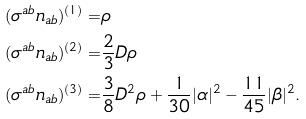Convert formula to latex. <formula><loc_0><loc_0><loc_500><loc_500>( \sigma ^ { a b } n _ { a b } ) ^ { ( 1 ) } = & \rho \\ ( \sigma ^ { a b } n _ { a b } ) ^ { ( 2 ) } = & \frac { 2 } { 3 } D \rho \\ ( \sigma ^ { a b } n _ { a b } ) ^ { ( 3 ) } = & \frac { 3 } { 8 } D ^ { 2 } \rho + \frac { 1 } { 3 0 } | \alpha | ^ { 2 } - \frac { 1 1 } { 4 5 } | \beta | ^ { 2 } .</formula> 